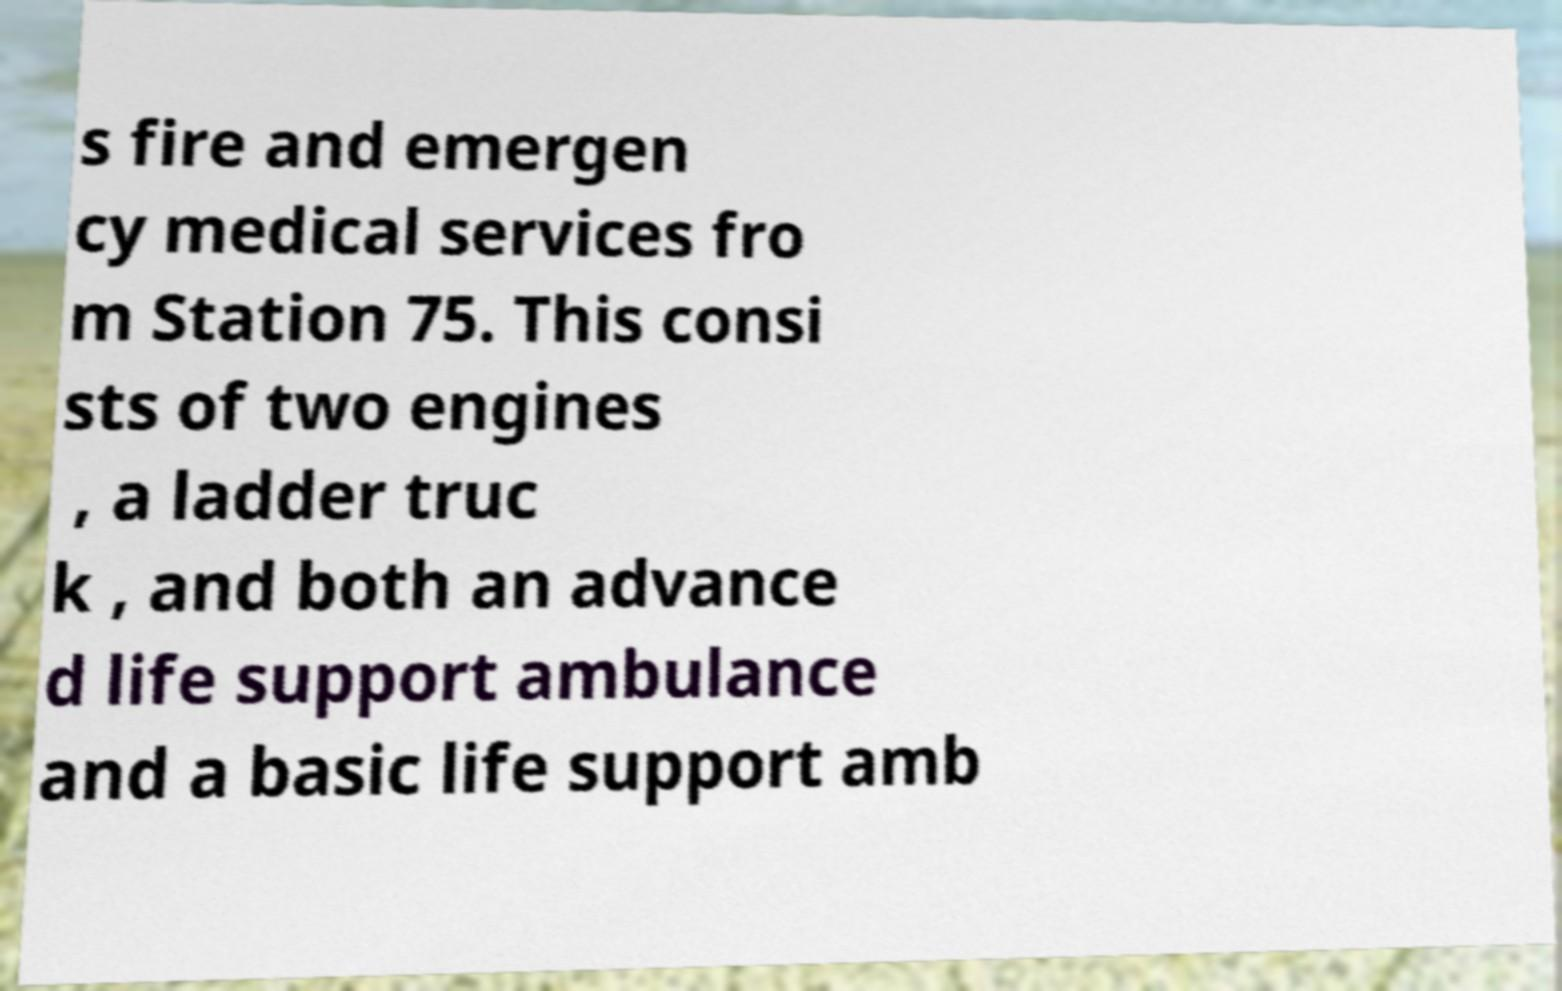Please identify and transcribe the text found in this image. s fire and emergen cy medical services fro m Station 75. This consi sts of two engines , a ladder truc k , and both an advance d life support ambulance and a basic life support amb 